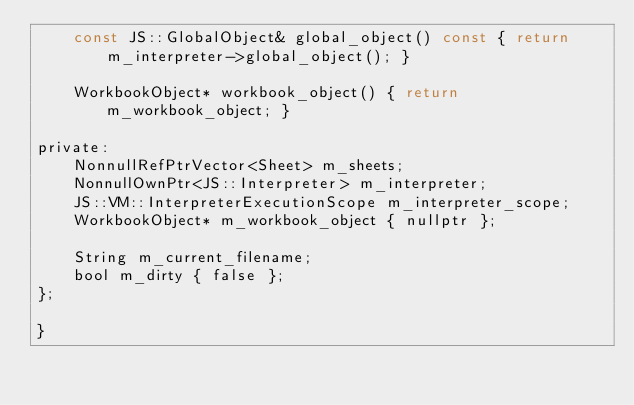Convert code to text. <code><loc_0><loc_0><loc_500><loc_500><_C_>    const JS::GlobalObject& global_object() const { return m_interpreter->global_object(); }

    WorkbookObject* workbook_object() { return m_workbook_object; }

private:
    NonnullRefPtrVector<Sheet> m_sheets;
    NonnullOwnPtr<JS::Interpreter> m_interpreter;
    JS::VM::InterpreterExecutionScope m_interpreter_scope;
    WorkbookObject* m_workbook_object { nullptr };

    String m_current_filename;
    bool m_dirty { false };
};

}
</code> 